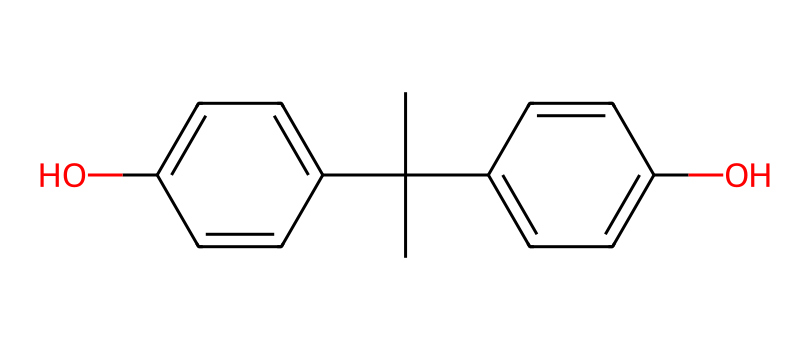What is the molecular formula of bisphenol A? To determine the molecular formula, count the number of carbon (C), hydrogen (H), and oxygen (O) atoms in the chemical structure. In this case, there are 15 carbon atoms, 16 hydrogen atoms, and 2 oxygen atoms. Therefore, the molecular formula is C15H16O2.
Answer: C15H16O2 How many hydroxyl (-OH) groups are present in this molecule? In the structure of bisphenol A, the hydroxyl groups are represented by the 'O' atoms that are connected to hydrogen atoms. There are two such groups in this molecule.
Answer: 2 What type of chemical compound is bisphenol A? Bisphenol A has two aromatic rings and contains hydroxyl groups, which classify it as a phenolic compound. Specifically, it is a diphenolic compound because it has two phenol groups.
Answer: diphenol What is the total number of rings in the bisphenol A structure? The structure of bisphenol A contains two benzene rings, which are cyclic aromatic structures. Therefore, the total number of rings is two.
Answer: 2 Does bisphenol A have any double bonds in its structure? To identify the presence of double bonds, look for the carbon-carbon double bonds in the aromatic rings. The presence of alternating double bonds indicates that bisphenol A has several double bonds, specifically between the carbon atoms in the aromatic rings.
Answer: yes 